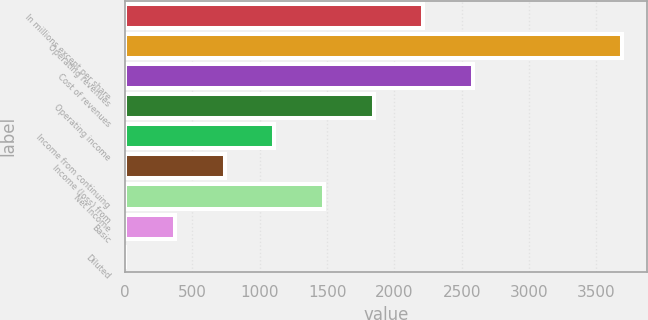<chart> <loc_0><loc_0><loc_500><loc_500><bar_chart><fcel>In millions except per share<fcel>Operating revenues<fcel>Cost of revenues<fcel>Operating income<fcel>Income from continuing<fcel>Income (loss) from<fcel>Net income<fcel>Basic<fcel>Diluted<nl><fcel>2215.7<fcel>3692<fcel>2584.77<fcel>1846.63<fcel>1108.49<fcel>739.42<fcel>1477.56<fcel>370.35<fcel>1.28<nl></chart> 